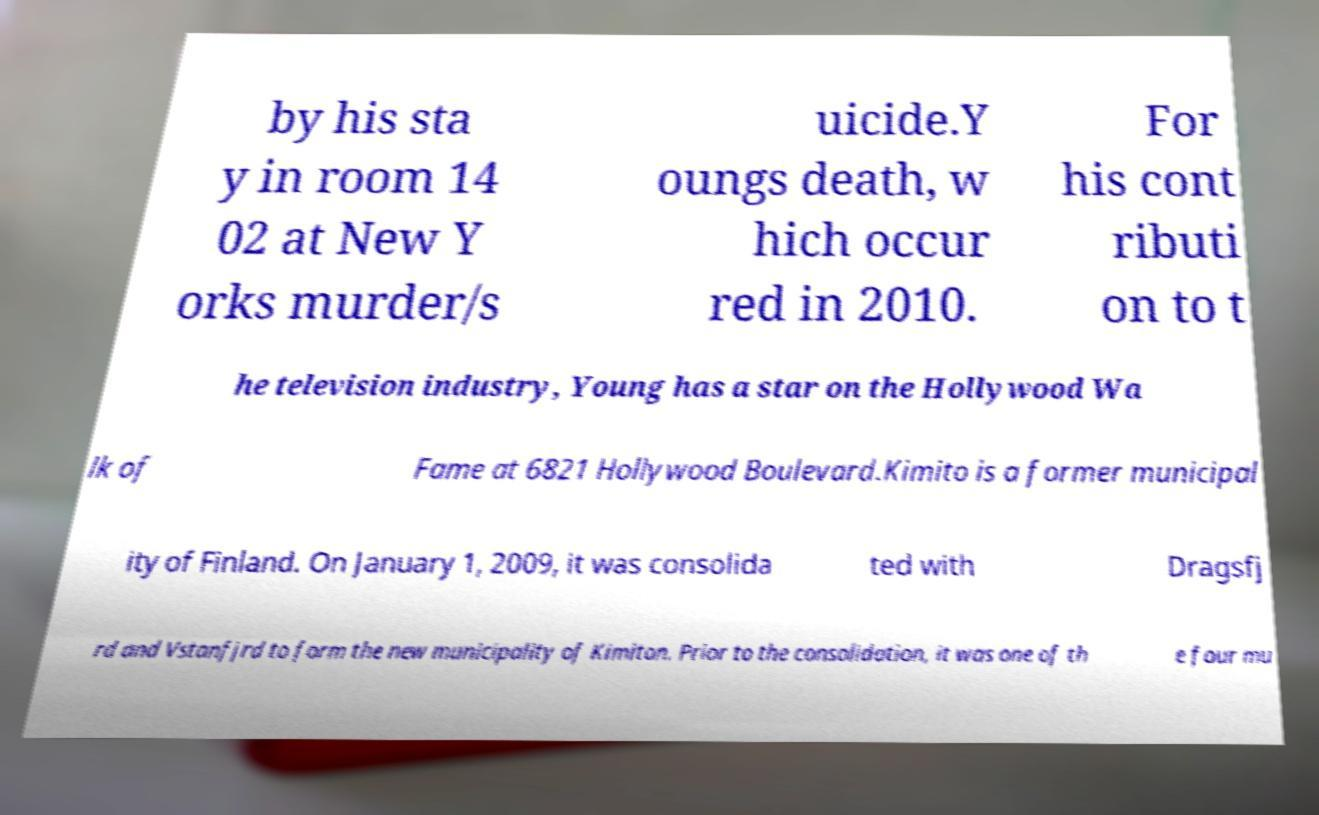Could you assist in decoding the text presented in this image and type it out clearly? by his sta y in room 14 02 at New Y orks murder/s uicide.Y oungs death, w hich occur red in 2010. For his cont ributi on to t he television industry, Young has a star on the Hollywood Wa lk of Fame at 6821 Hollywood Boulevard.Kimito is a former municipal ity of Finland. On January 1, 2009, it was consolida ted with Dragsfj rd and Vstanfjrd to form the new municipality of Kimiton. Prior to the consolidation, it was one of th e four mu 